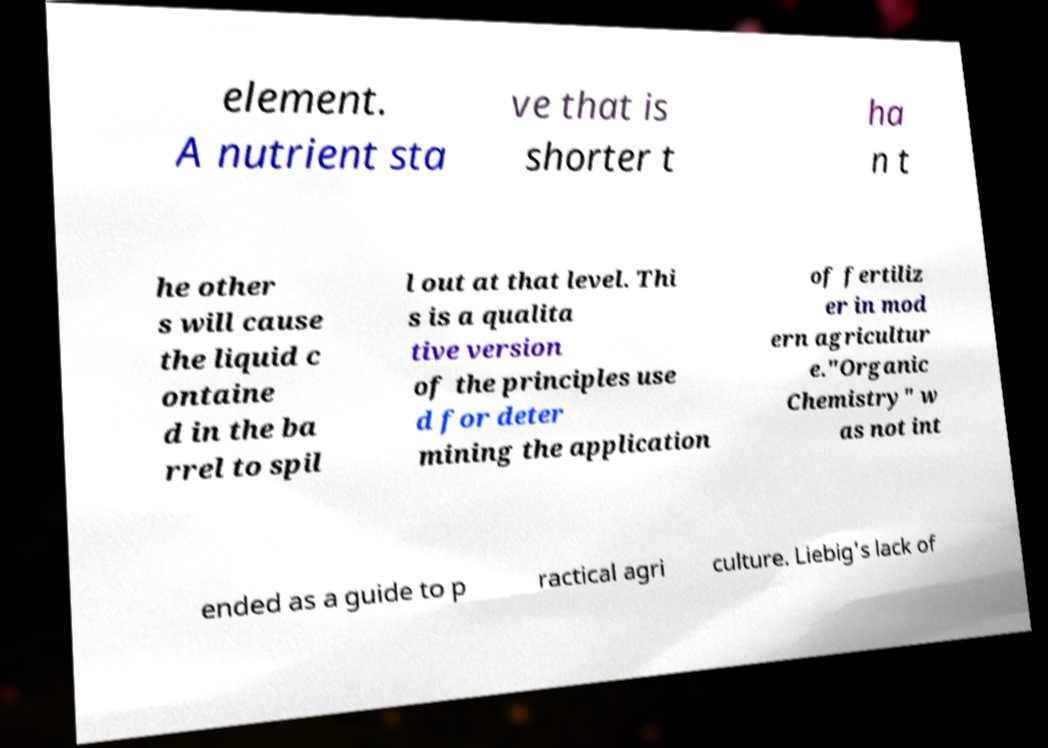What messages or text are displayed in this image? I need them in a readable, typed format. element. A nutrient sta ve that is shorter t ha n t he other s will cause the liquid c ontaine d in the ba rrel to spil l out at that level. Thi s is a qualita tive version of the principles use d for deter mining the application of fertiliz er in mod ern agricultur e."Organic Chemistry" w as not int ended as a guide to p ractical agri culture. Liebig's lack of 